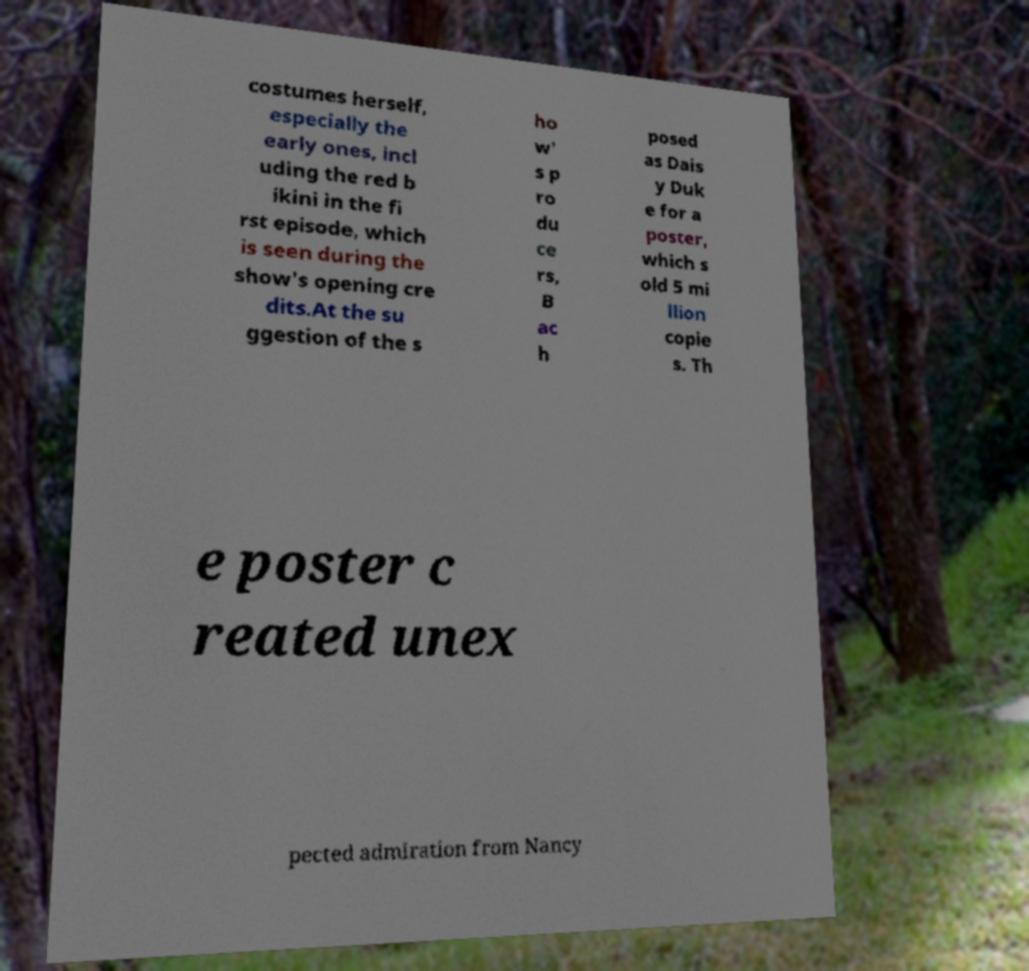For documentation purposes, I need the text within this image transcribed. Could you provide that? costumes herself, especially the early ones, incl uding the red b ikini in the fi rst episode, which is seen during the show's opening cre dits.At the su ggestion of the s ho w' s p ro du ce rs, B ac h posed as Dais y Duk e for a poster, which s old 5 mi llion copie s. Th e poster c reated unex pected admiration from Nancy 